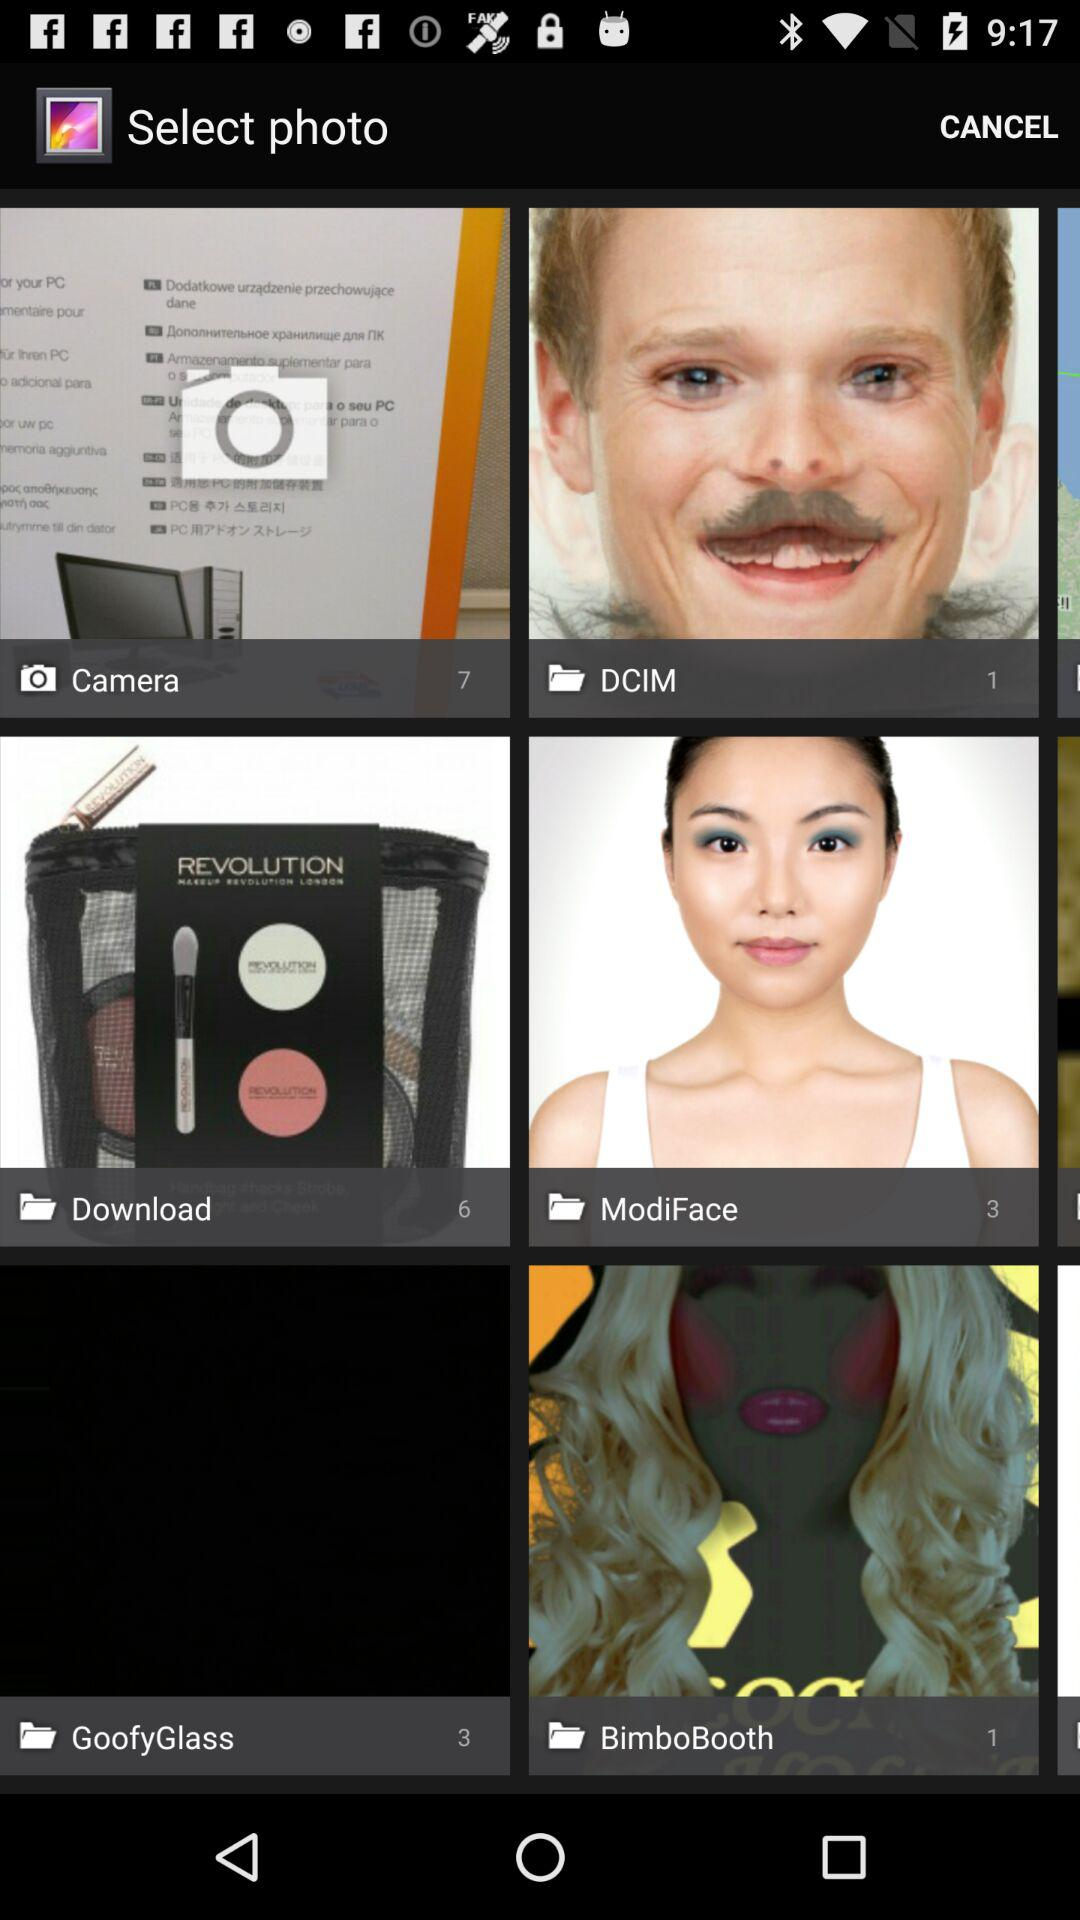Which are the different options to select photos? The different options to select photos are "Camera", "DCIM", "Download", "ModiFace", "GoofyGlass" and "BimboBooth". 